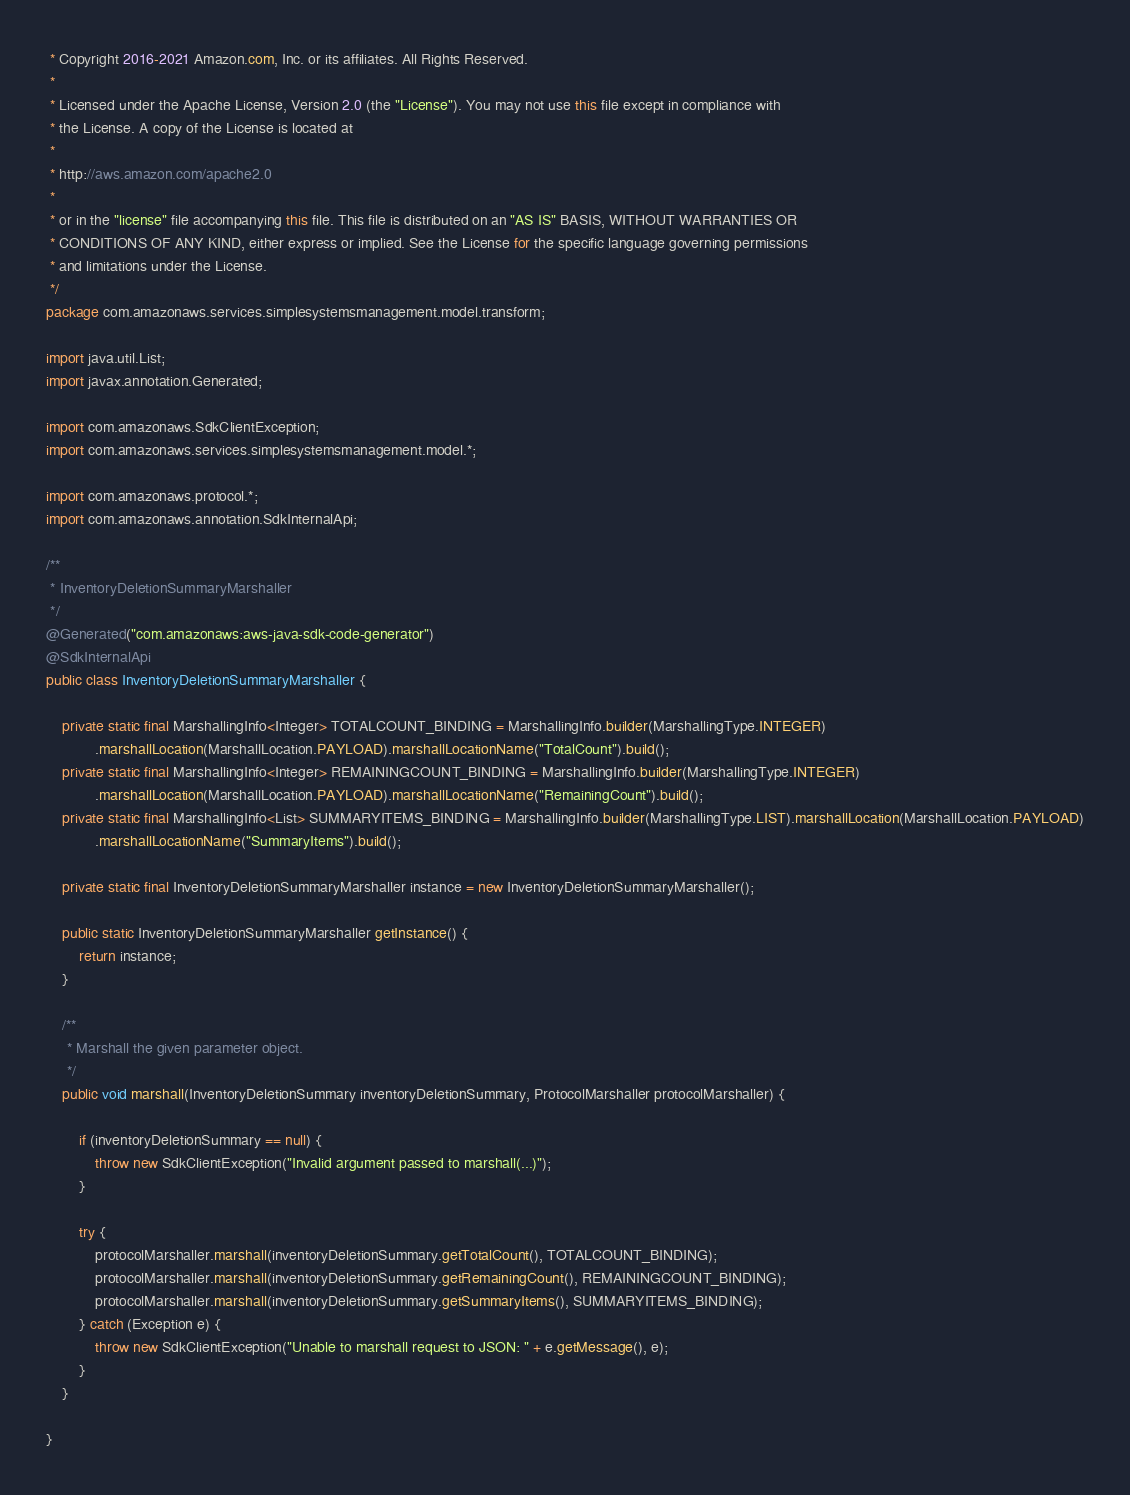Convert code to text. <code><loc_0><loc_0><loc_500><loc_500><_Java_> * Copyright 2016-2021 Amazon.com, Inc. or its affiliates. All Rights Reserved.
 * 
 * Licensed under the Apache License, Version 2.0 (the "License"). You may not use this file except in compliance with
 * the License. A copy of the License is located at
 * 
 * http://aws.amazon.com/apache2.0
 * 
 * or in the "license" file accompanying this file. This file is distributed on an "AS IS" BASIS, WITHOUT WARRANTIES OR
 * CONDITIONS OF ANY KIND, either express or implied. See the License for the specific language governing permissions
 * and limitations under the License.
 */
package com.amazonaws.services.simplesystemsmanagement.model.transform;

import java.util.List;
import javax.annotation.Generated;

import com.amazonaws.SdkClientException;
import com.amazonaws.services.simplesystemsmanagement.model.*;

import com.amazonaws.protocol.*;
import com.amazonaws.annotation.SdkInternalApi;

/**
 * InventoryDeletionSummaryMarshaller
 */
@Generated("com.amazonaws:aws-java-sdk-code-generator")
@SdkInternalApi
public class InventoryDeletionSummaryMarshaller {

    private static final MarshallingInfo<Integer> TOTALCOUNT_BINDING = MarshallingInfo.builder(MarshallingType.INTEGER)
            .marshallLocation(MarshallLocation.PAYLOAD).marshallLocationName("TotalCount").build();
    private static final MarshallingInfo<Integer> REMAININGCOUNT_BINDING = MarshallingInfo.builder(MarshallingType.INTEGER)
            .marshallLocation(MarshallLocation.PAYLOAD).marshallLocationName("RemainingCount").build();
    private static final MarshallingInfo<List> SUMMARYITEMS_BINDING = MarshallingInfo.builder(MarshallingType.LIST).marshallLocation(MarshallLocation.PAYLOAD)
            .marshallLocationName("SummaryItems").build();

    private static final InventoryDeletionSummaryMarshaller instance = new InventoryDeletionSummaryMarshaller();

    public static InventoryDeletionSummaryMarshaller getInstance() {
        return instance;
    }

    /**
     * Marshall the given parameter object.
     */
    public void marshall(InventoryDeletionSummary inventoryDeletionSummary, ProtocolMarshaller protocolMarshaller) {

        if (inventoryDeletionSummary == null) {
            throw new SdkClientException("Invalid argument passed to marshall(...)");
        }

        try {
            protocolMarshaller.marshall(inventoryDeletionSummary.getTotalCount(), TOTALCOUNT_BINDING);
            protocolMarshaller.marshall(inventoryDeletionSummary.getRemainingCount(), REMAININGCOUNT_BINDING);
            protocolMarshaller.marshall(inventoryDeletionSummary.getSummaryItems(), SUMMARYITEMS_BINDING);
        } catch (Exception e) {
            throw new SdkClientException("Unable to marshall request to JSON: " + e.getMessage(), e);
        }
    }

}
</code> 